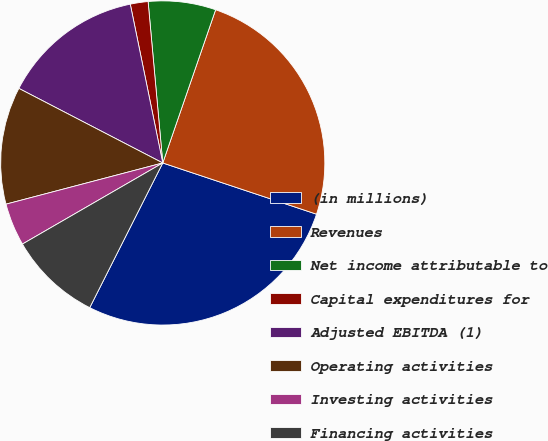<chart> <loc_0><loc_0><loc_500><loc_500><pie_chart><fcel>(in millions)<fcel>Revenues<fcel>Net income attributable to<fcel>Capital expenditures for<fcel>Adjusted EBITDA (1)<fcel>Operating activities<fcel>Investing activities<fcel>Financing activities<nl><fcel>27.32%<fcel>24.83%<fcel>6.73%<fcel>1.77%<fcel>14.18%<fcel>11.7%<fcel>4.25%<fcel>9.22%<nl></chart> 